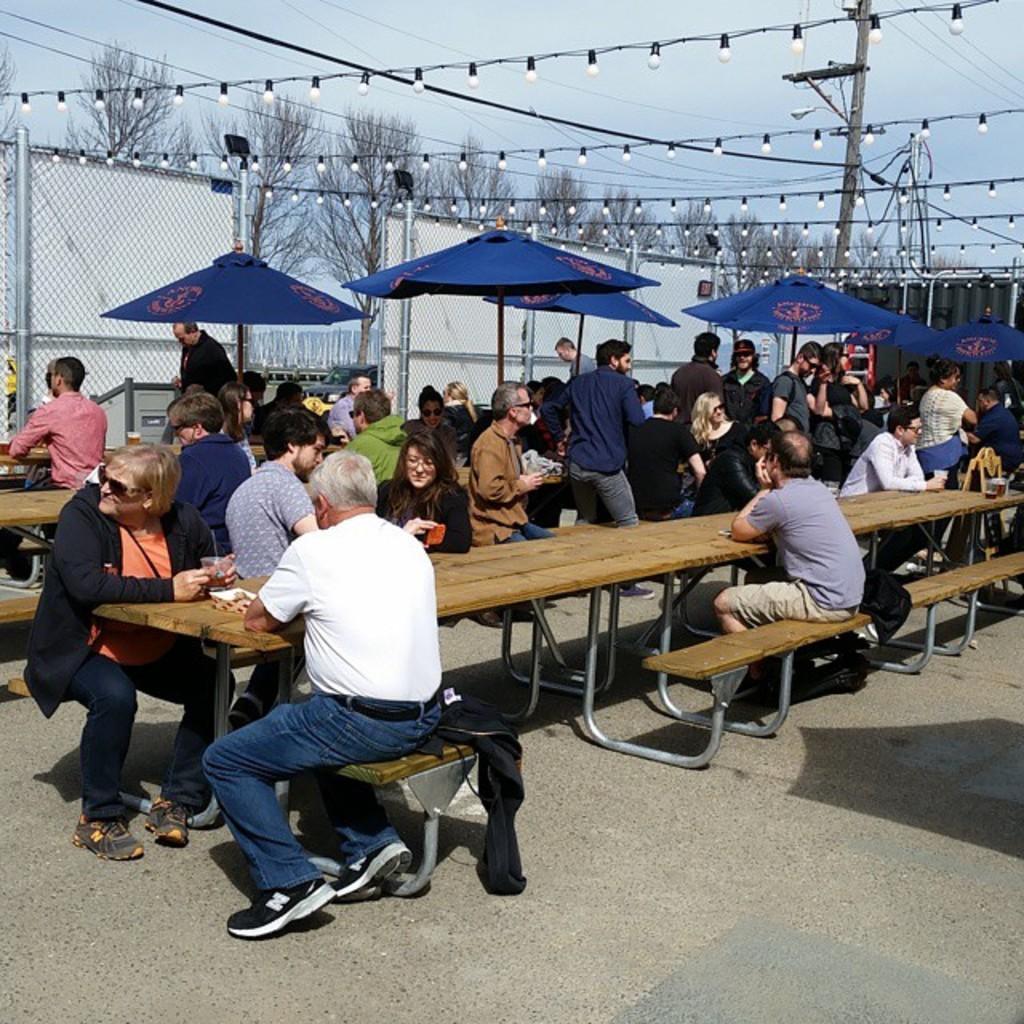Could you give a brief overview of what you see in this image? In this image, we can see a group of people sitting on the bench in front of the table. In the background, we can also see a few people are walking, umbrella, net fence, lights, trees, electric pole. At the top, we can see a sky, at the bottom, we can see a road. 